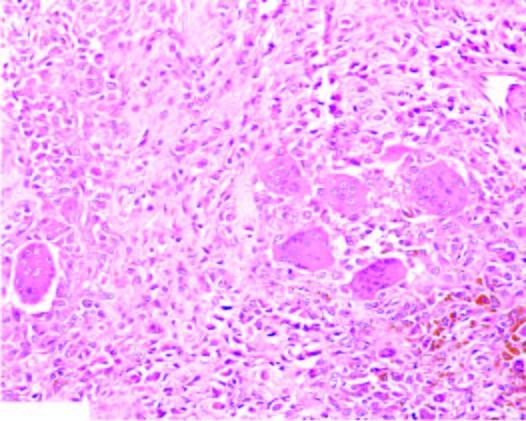does the tumour show infiltrate of small oval to spindled histiocytes with numerous interspersed multinucleate giant cells lyning in a background of fibrous tissue?
Answer the question using a single word or phrase. Yes 